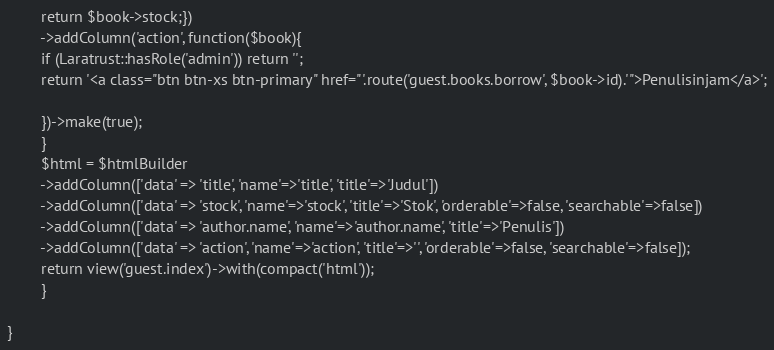<code> <loc_0><loc_0><loc_500><loc_500><_PHP_>		return $book->stock;})
		->addColumn('action', function($book){
		if (Laratrust::hasRole('admin')) return '';
		return '<a class="btn btn-xs btn-primary" href="'.route('guest.books.borrow', $book->id).'">Penulisinjam</a>';

		})->make(true);
		}
		$html = $htmlBuilder
		->addColumn(['data' => 'title', 'name'=>'title', 'title'=>'Judul'])
		->addColumn(['data' => 'stock', 'name'=>'stock', 'title'=>'Stok', 'orderable'=>false, 'searchable'=>false])
		->addColumn(['data' => 'author.name', 'name'=>'author.name', 'title'=>'Penulis'])
		->addColumn(['data' => 'action', 'name'=>'action', 'title'=>'', 'orderable'=>false, 'searchable'=>false]);
		return view('guest.index')->with(compact('html'));
		}

}
</code> 